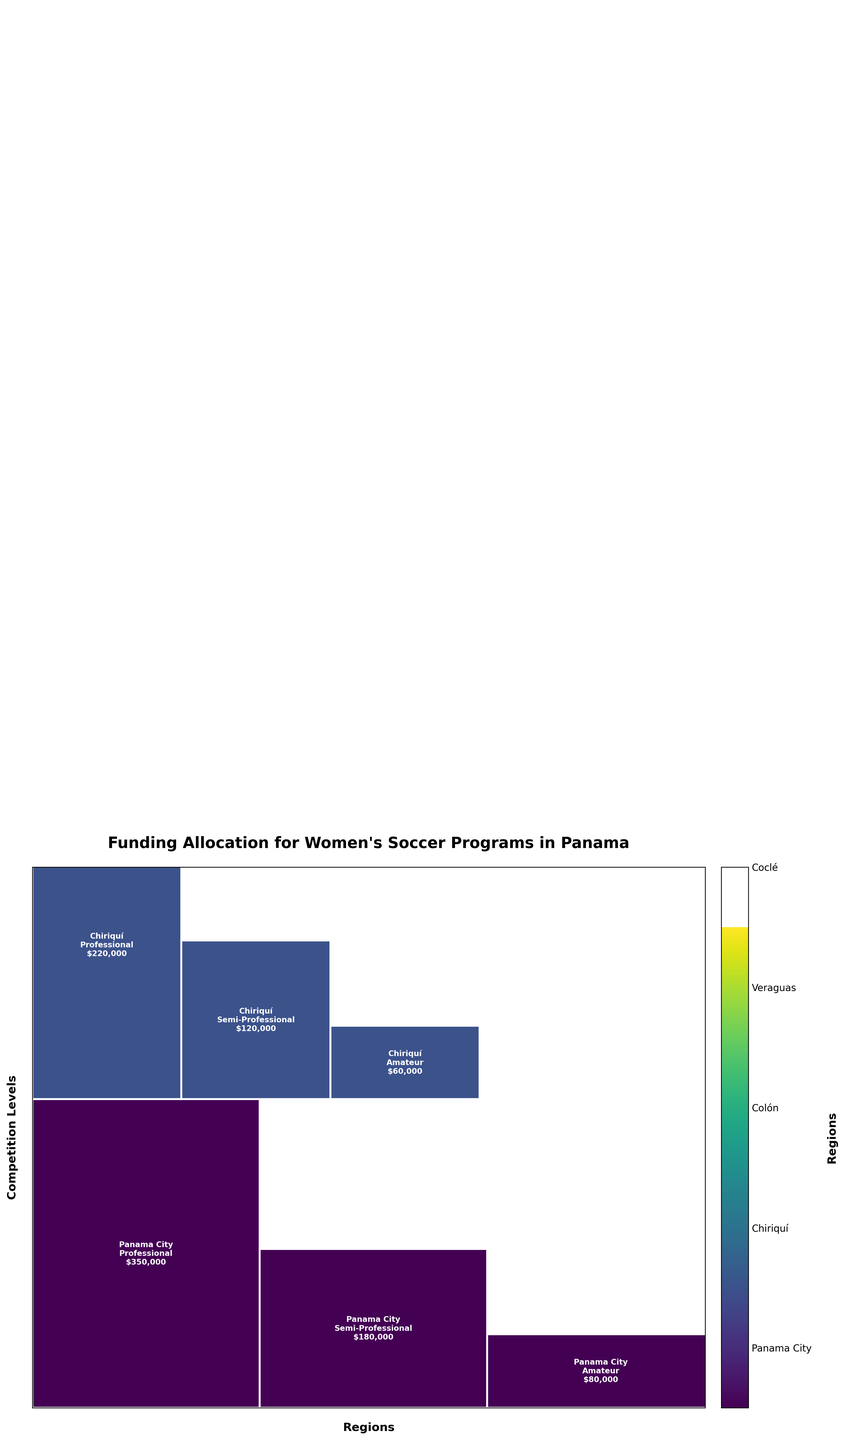What are the regions shown in the figure? The regions can be identified by the color legend on the figure. The regions listed are Panama City, Chiriquí, Colón, Veraguas, and Coclé.
Answer: Panama City, Chiriquí, Colón, Veraguas, Coclé Which region receives the highest funding for professional level competition? Since each region has its funding amounts labeled and proportional widths, Panama City has the largest rectangle for professional level competition, indicating it receives the highest funding at this level.
Answer: Panama City What is the total funding allocated to Veraguas for all competition levels? By summing the funding amounts for Veraguas from the figure: $150,000 (Professional) + $75,000 (Semi-Professional) + $35,000 (Amateur) = $260,000.
Answer: $260,000 Compare the funding allocation for semi-professional competition between Panama City and Coclé. Which receives more and by how much? Panama City receives $180,000 for semi-professional, while Coclé receives $65,000. The difference is calculated as $180,000 - $65,000 = $115,000.
Answer: Panama City, by $115,000 What is the overall pattern of funding distribution among different competition levels? From the size of the rectangles, we observe that professional levels generally receive the highest funding, followed by semi-professional, and then amateur levels.
Answer: Professional > Semi-Professional > Amateur How does the funding for amateur competition in Chiriquí compare to that in Colón? The figure indicates that Chiriquí receives $60,000 for amateur competition, while Colón receives $40,000. Chiriquí receives more.
Answer: Chiriquí What's the total funding allocated across all regions for professional level competitions? By summing the funding amounts for Professional levels across all regions: $350,000 (Panama City) + $220,000 (Chiriquí) + $180,000 (Colón) + $150,000 (Veraguas) + $130,000 (Coclé) = $1,030,000.
Answer: $1,030,000 Which competition level in Coclé receives the least funding? By referring to the funding allocations for Coclé, the amateur level receives the least funding at $30,000.
Answer: Amateur Does any region receive an equal amount of funding for any two different competition levels? In the figure, for each region, the funding amounts differ across competition levels; no two competition levels within the same region receive an equal amount of funding.
Answer: No 